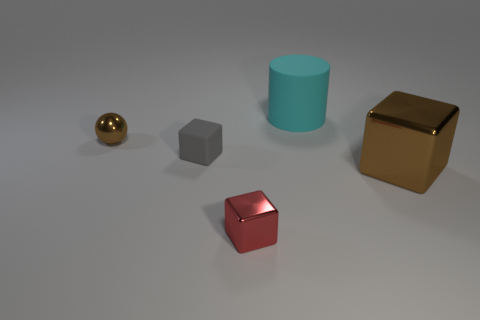What can you infer about the lighting source in this scene? The lighting in the scene comes from above, as evidenced by the direction of the shadows cast by the objects. The shadows are soft-edged, indicating the light source is not overly harsh and is probably simulating a diffuse, overcast sky or a soft artificial light. 